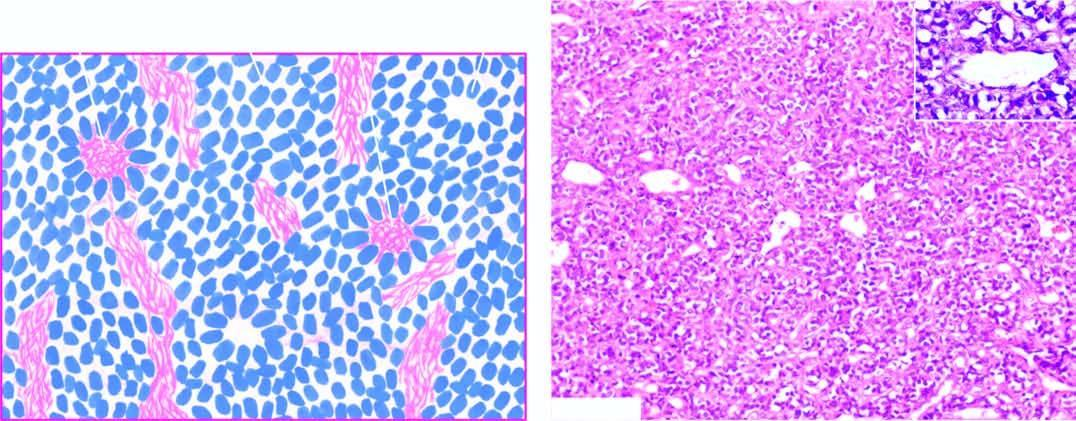what shows a close-up view of pseudorosette?
Answer the question using a single word or phrase. Inset 